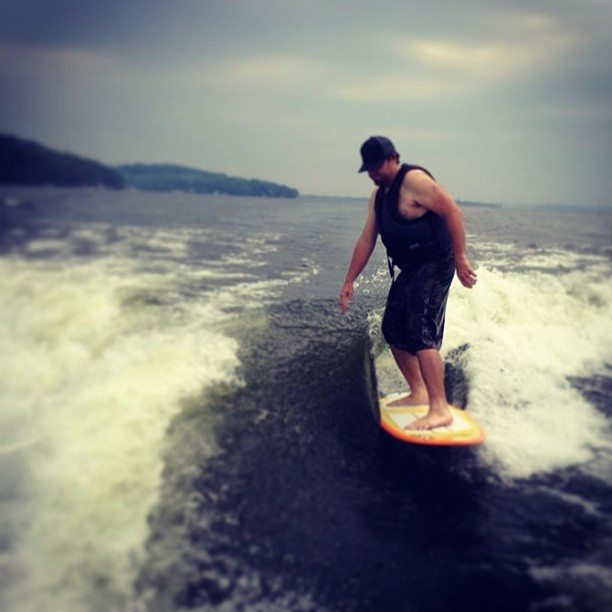Describe the objects in this image and their specific colors. I can see people in darkblue, navy, brown, gray, and purple tones and surfboard in darkblue, khaki, tan, and beige tones in this image. 